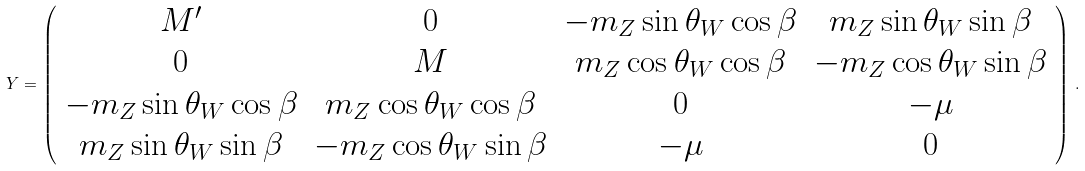<formula> <loc_0><loc_0><loc_500><loc_500>Y = \left ( \begin{array} { c c c c } M ^ { \prime } & 0 & - m _ { Z } \sin \theta _ { W } \cos \beta & m _ { Z } \sin \theta _ { W } \sin \beta \\ 0 & M & m _ { Z } \cos \theta _ { W } \cos \beta & - m _ { Z } \cos \theta _ { W } \sin \beta \\ - m _ { Z } \sin \theta _ { W } \cos \beta & m _ { Z } \cos \theta _ { W } \cos \beta & 0 & - \mu \\ m _ { Z } \sin \theta _ { W } \sin \beta & - m _ { Z } \cos \theta _ { W } \sin \beta & - \mu & 0 \end{array} \right ) \, .</formula> 